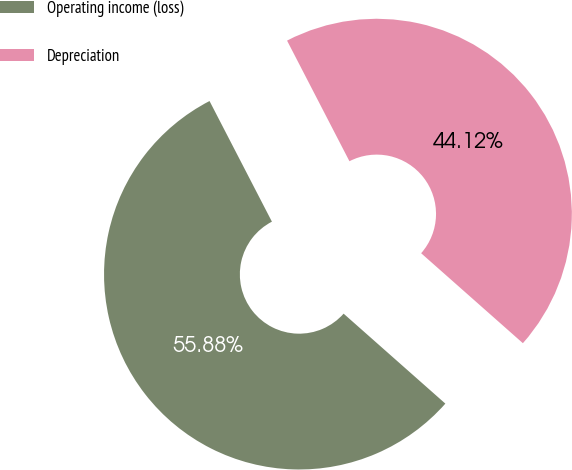Convert chart. <chart><loc_0><loc_0><loc_500><loc_500><pie_chart><fcel>Operating income (loss)<fcel>Depreciation<nl><fcel>55.88%<fcel>44.12%<nl></chart> 